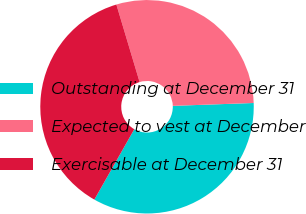<chart> <loc_0><loc_0><loc_500><loc_500><pie_chart><fcel>Outstanding at December 31<fcel>Expected to vest at December<fcel>Exercisable at December 31<nl><fcel>33.78%<fcel>29.07%<fcel>37.15%<nl></chart> 